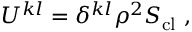<formula> <loc_0><loc_0><loc_500><loc_500>U ^ { k l } = \delta ^ { k l } \rho ^ { 2 } S _ { c l } \ ,</formula> 